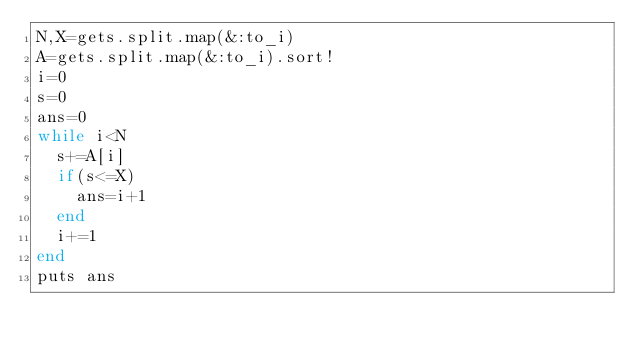Convert code to text. <code><loc_0><loc_0><loc_500><loc_500><_Ruby_>N,X=gets.split.map(&:to_i)
A=gets.split.map(&:to_i).sort!
i=0
s=0
ans=0
while i<N
  s+=A[i]
  if(s<=X)
    ans=i+1
  end
  i+=1
end
puts ans</code> 